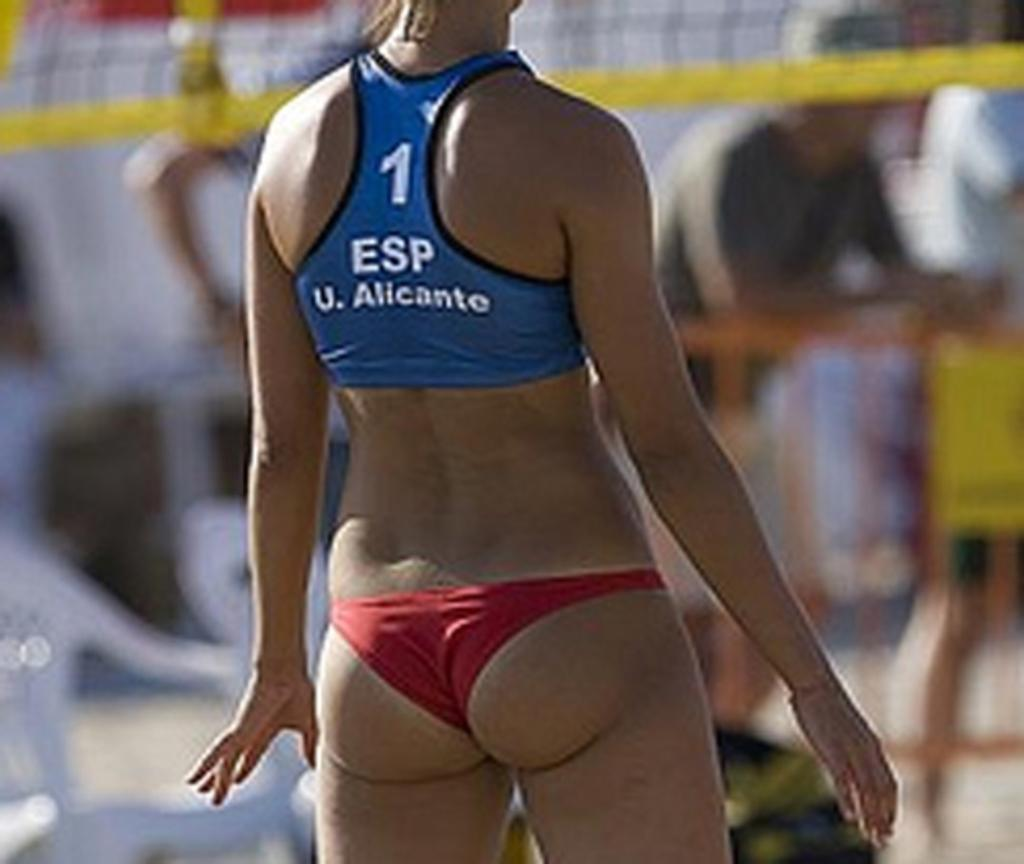<image>
Give a short and clear explanation of the subsequent image. A woman playing volleyball with 1 ESP printed on the back of her blue shirt. 